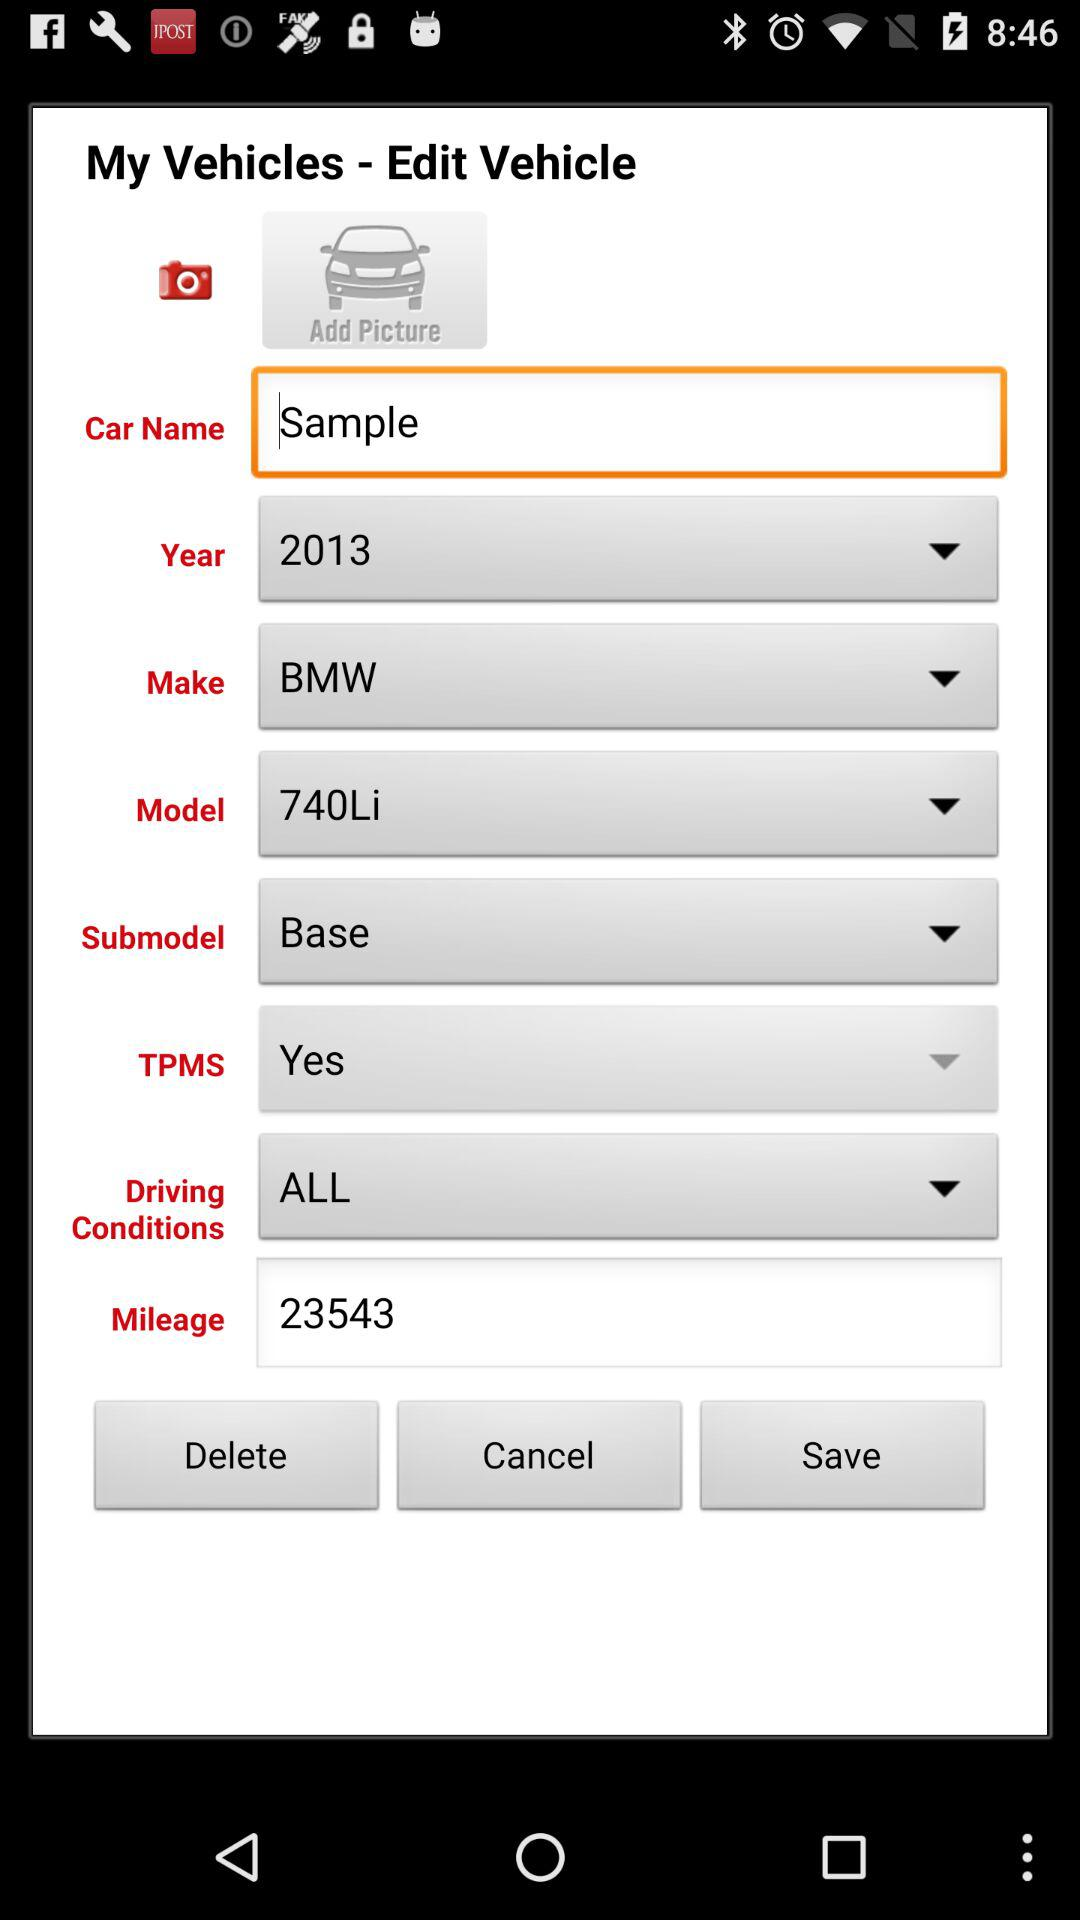What is the name of the application? The name of the application is "My Vehicles". 